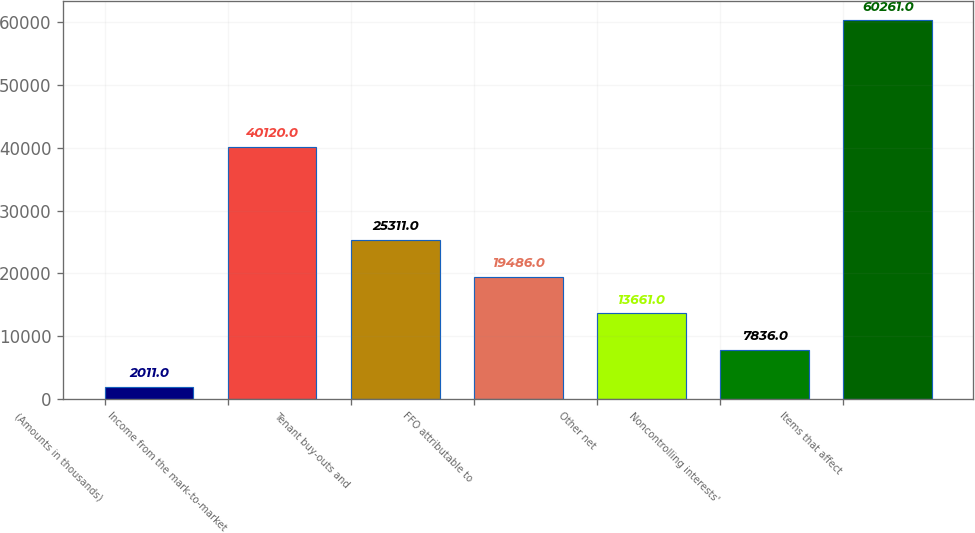Convert chart. <chart><loc_0><loc_0><loc_500><loc_500><bar_chart><fcel>(Amounts in thousands)<fcel>Income from the mark-to-market<fcel>Tenant buy-outs and<fcel>FFO attributable to<fcel>Other net<fcel>Noncontrolling interests'<fcel>Items that affect<nl><fcel>2011<fcel>40120<fcel>25311<fcel>19486<fcel>13661<fcel>7836<fcel>60261<nl></chart> 